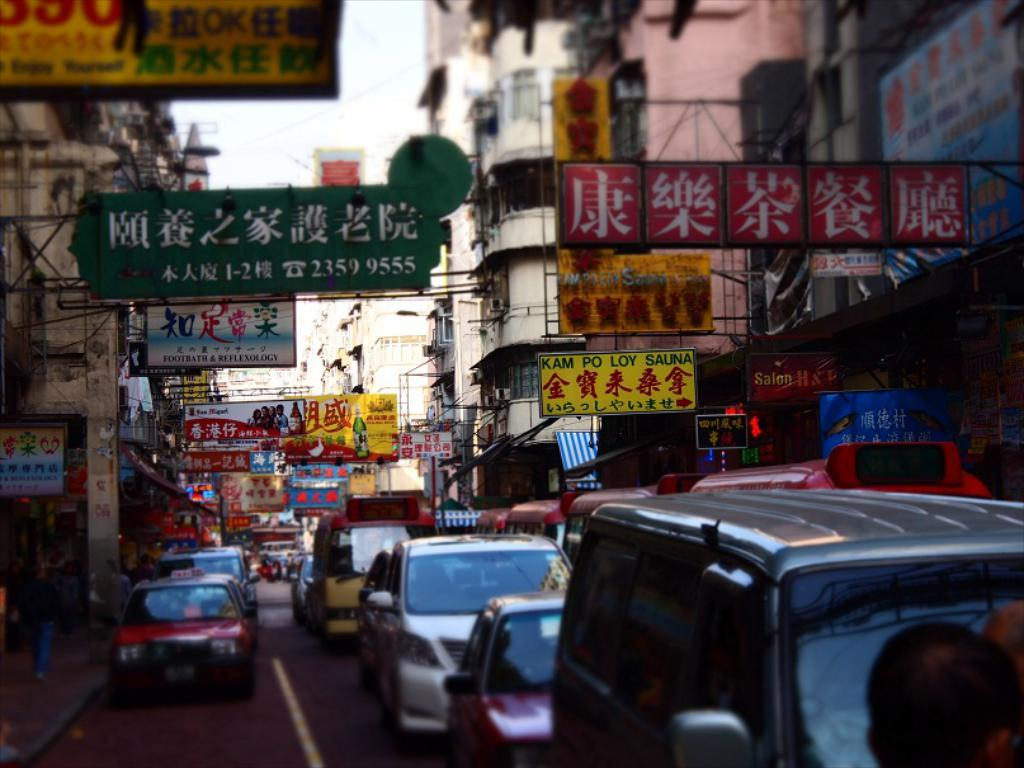<image>
Relay a brief, clear account of the picture shown. A sign advertises KAM PO LOY Sauna on the busy streets of Japan. 